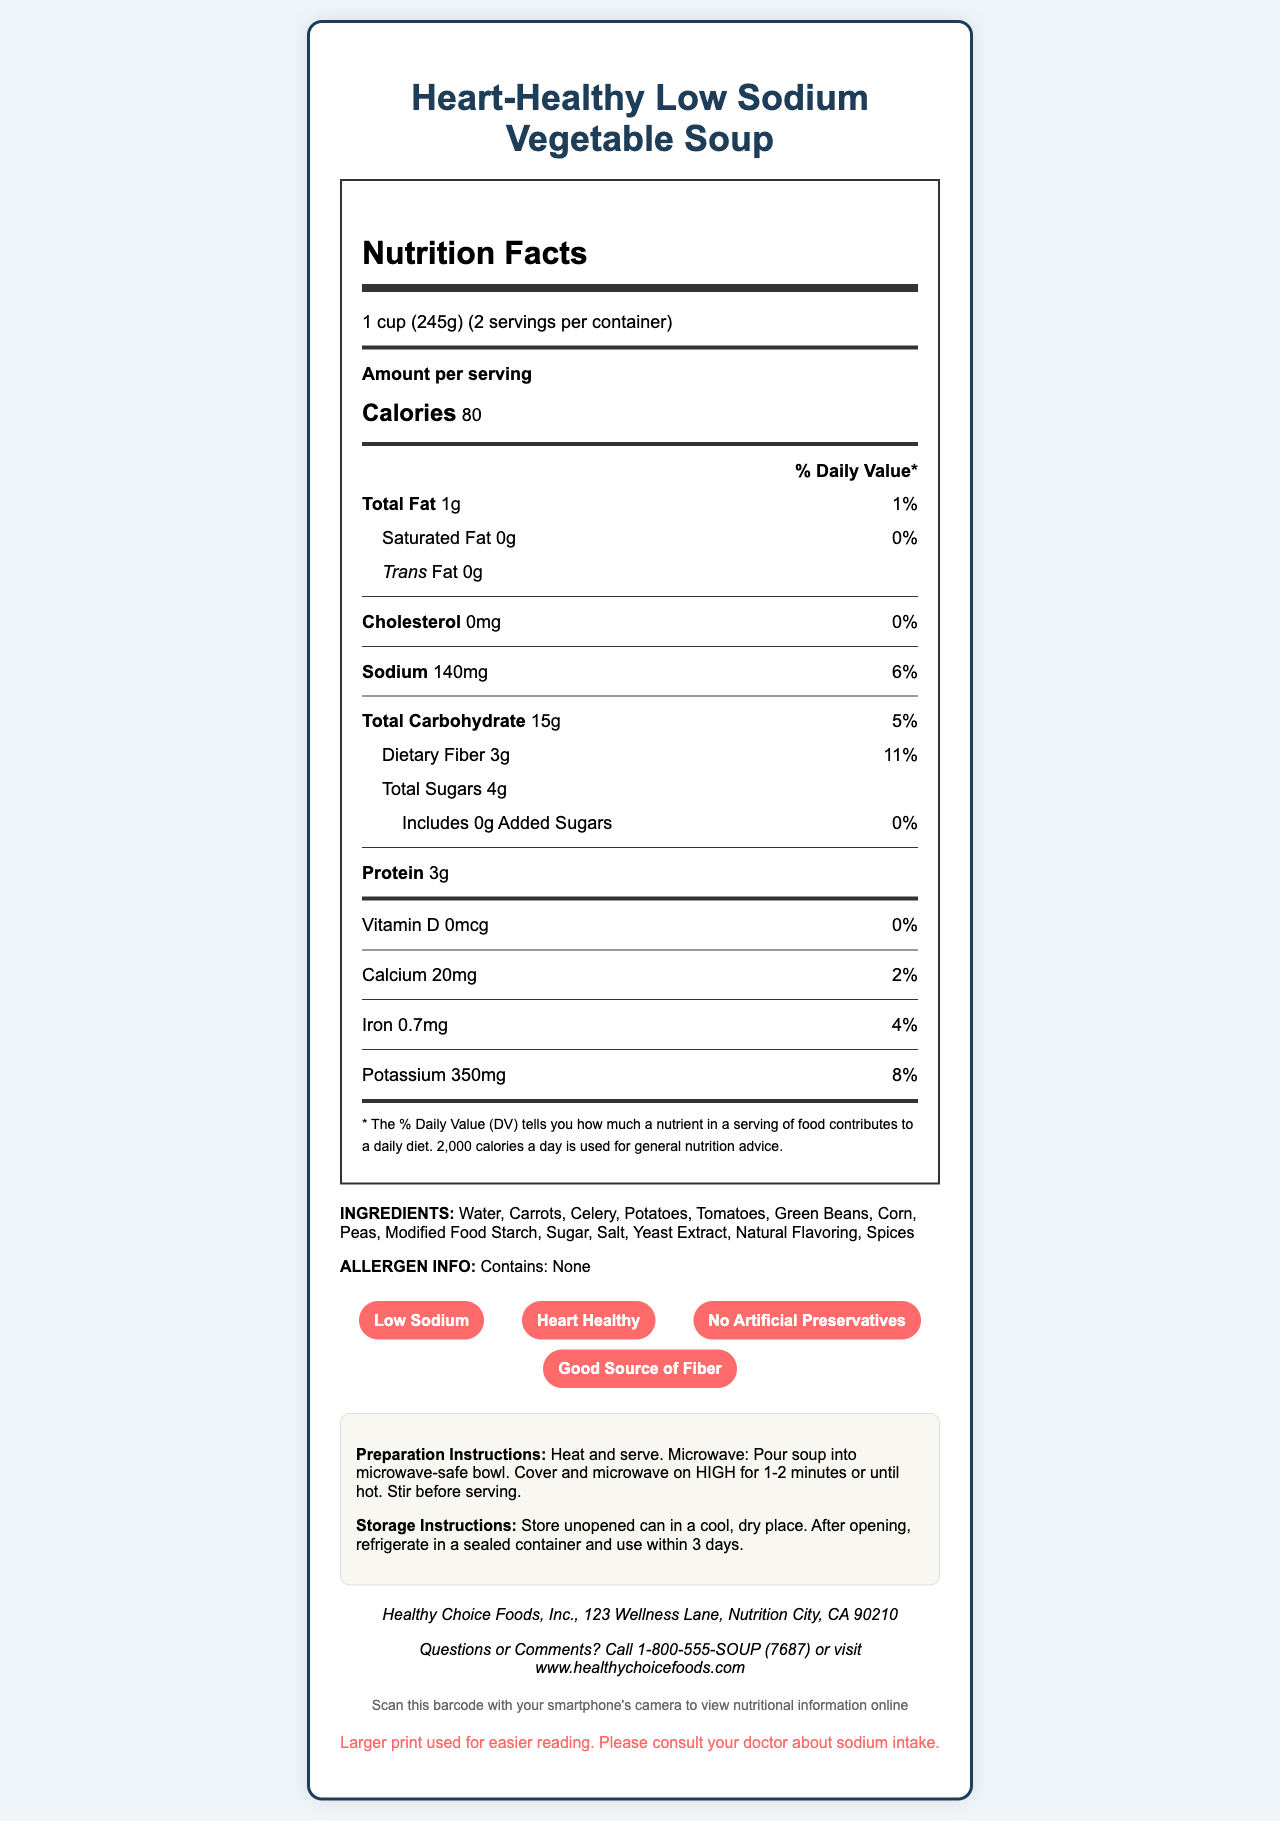what is the serving size for the soup? The serving size is mentioned at the top of the Nutrition Facts part of the label.
Answer: 1 cup (245g) how many calories are in one serving? The calories per serving are listed as "Calories 80" in the Nutrition Facts section.
Answer: 80 how many servings are in the container? The number of servings per container is given as "2 servings per container" in the Nutrition Facts section.
Answer: 2 what percentage of the daily value of sodium does one serving contain? The sodium content and its daily value percentage (%DV) are listed together: "Sodium 140mg - 6%".
Answer: 6% what is the total fat content in one serving? The total fat content is mentioned as "Total Fat 1g".
Answer: 1g does this soup contain any trans fat? The label mentions "Trans Fat 0g", indicating there is no trans fat.
Answer: No how much protein is in one serving of this soup? The label states "Protein 3g".
Answer: 3g what are the main ingredients listed in the soup? The ingredients are listed under the Ingredients section.
Answer: Water, Carrots, Celery, Potatoes, Tomatoes, Green Beans, Corn, Peas, Modified Food Starch, Sugar, Salt, Yeast Extract, Natural Flavoring, Spices what is the manufacturer’s contact information? Contact details are provided under Manufacturer Info and Contact Info sections.
Answer: Healthy Choice Foods, Inc., 123 Wellness Lane, Nutrition City, CA 90210 how should the soup be stored after opening? The storage instructions specify this process under Storage Instructions.
Answer: Refrigerate in a sealed container and use within 3 days choose the correct daily value for dietary fiber in one serving: A. 5% B. 10% C. 11% D. 15% The daily value for dietary fiber is mentioned as "11%" next to "Dietary Fiber 3g".
Answer: C how much calcium is in one serving of the soup? A. 10mg B. 20mg C. 30mg D. 40mg The label reads "Calcium 20mg".
Answer: B does this product contain any allergens? The Allergen Info section states "Contains: None".
Answer: No is this soup considered heart-healthy? The soup is labeled as "Heart Healthy" in the special features.
Answer: Yes summarize the main nutritional qualities of the soup. The summary encompasses the main nutritional details and special features of the soup.
Answer: This low-sodium vegetable soup contains 80 calories per serving, with 1g total fat, 140mg sodium, 15g carbohydrates (including 3g dietary fiber and 4g total sugars), and 3g protein. It is heart-healthy, low in sodium, and has no artificial preservatives. where was this soup manufactured? The document does not provide the manufacturing location details, only the manufacturer's address for contact.
Answer: Cannot be determined 